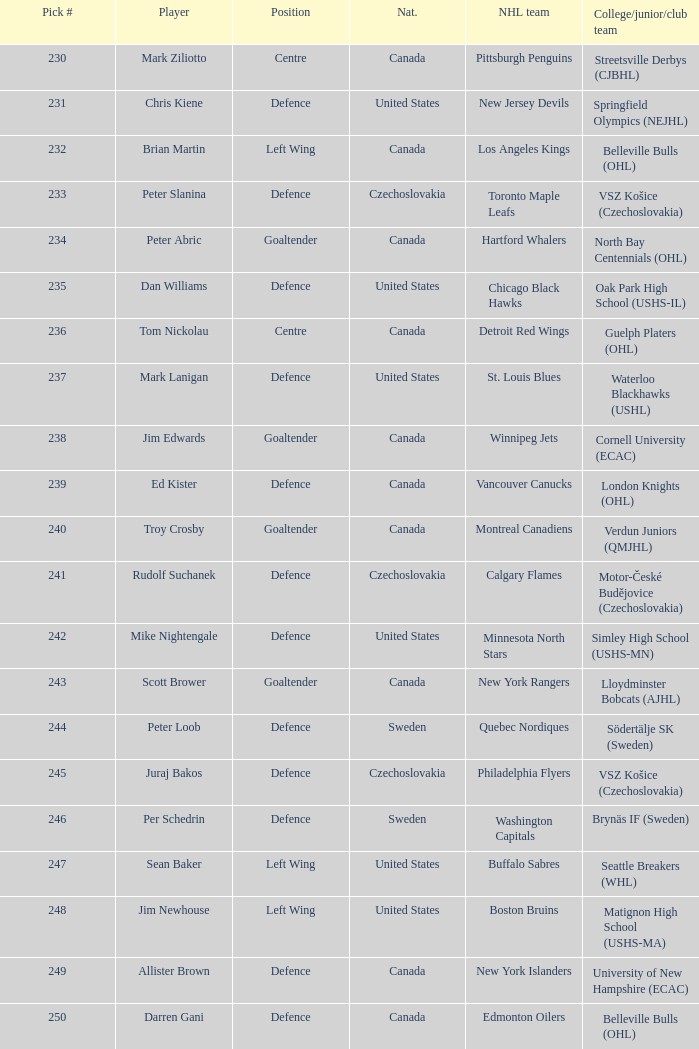What selection was the springfield olympics (nejhl)? 231.0. 